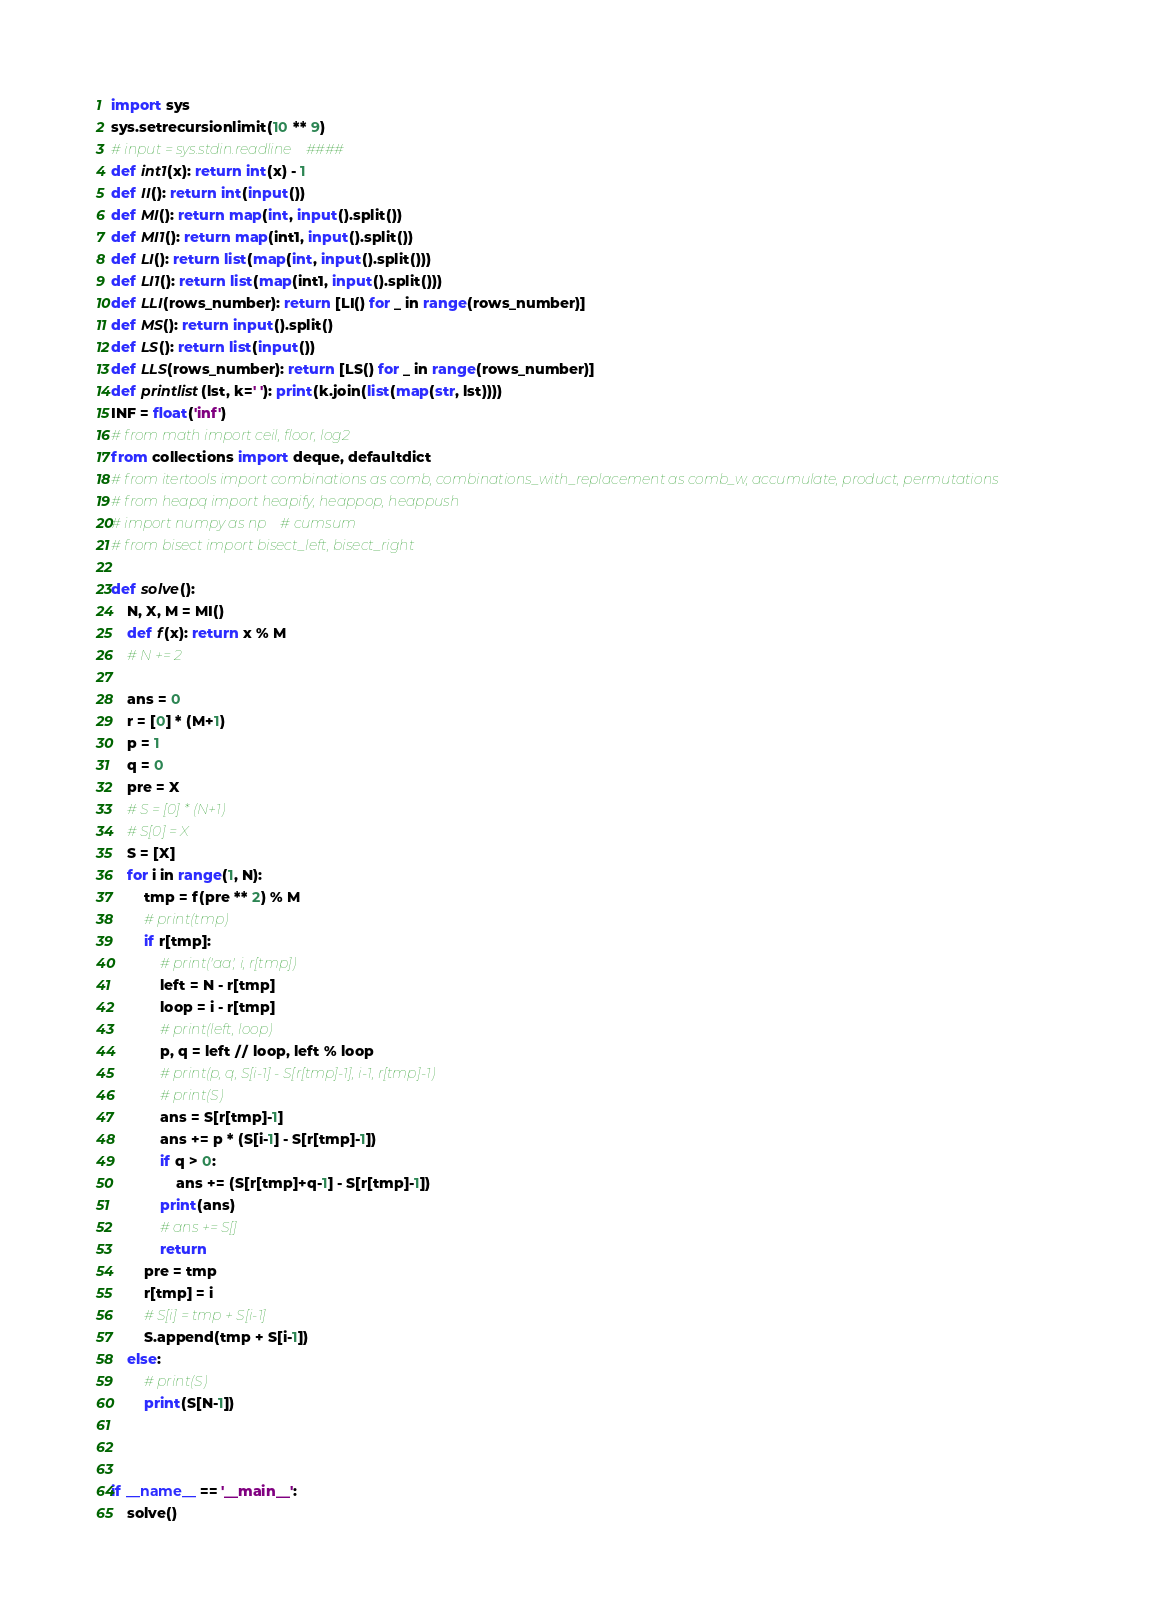<code> <loc_0><loc_0><loc_500><loc_500><_Python_>import sys
sys.setrecursionlimit(10 ** 9)
# input = sys.stdin.readline    ####
def int1(x): return int(x) - 1
def II(): return int(input())
def MI(): return map(int, input().split())
def MI1(): return map(int1, input().split())
def LI(): return list(map(int, input().split()))
def LI1(): return list(map(int1, input().split()))
def LLI(rows_number): return [LI() for _ in range(rows_number)]
def MS(): return input().split()
def LS(): return list(input())
def LLS(rows_number): return [LS() for _ in range(rows_number)]
def printlist(lst, k=' '): print(k.join(list(map(str, lst))))
INF = float('inf')
# from math import ceil, floor, log2
from collections import deque, defaultdict
# from itertools import combinations as comb, combinations_with_replacement as comb_w, accumulate, product, permutations
# from heapq import heapify, heappop, heappush
# import numpy as np    # cumsum
# from bisect import bisect_left, bisect_right

def solve():
    N, X, M = MI()
    def f(x): return x % M
    # N += 2

    ans = 0
    r = [0] * (M+1)
    p = 1
    q = 0
    pre = X
    # S = [0] * (N+1)
    # S[0] = X
    S = [X]
    for i in range(1, N):
        tmp = f(pre ** 2) % M
        # print(tmp)
        if r[tmp]:
            # print('aa', i, r[tmp])
            left = N - r[tmp]
            loop = i - r[tmp]
            # print(left, loop)
            p, q = left // loop, left % loop
            # print(p, q, S[i-1] - S[r[tmp]-1], i-1, r[tmp]-1)
            # print(S)
            ans = S[r[tmp]-1]
            ans += p * (S[i-1] - S[r[tmp]-1])
            if q > 0:
                ans += (S[r[tmp]+q-1] - S[r[tmp]-1])
            print(ans)
            # ans += S[]
            return 
        pre = tmp
        r[tmp] = i
        # S[i] = tmp + S[i-1]
        S.append(tmp + S[i-1])
    else:
        # print(S)
        print(S[N-1])



if __name__ == '__main__':
    solve()

</code> 